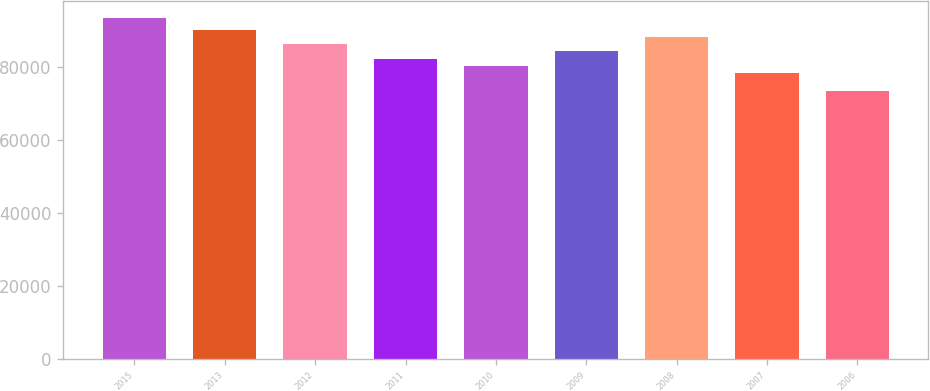Convert chart. <chart><loc_0><loc_0><loc_500><loc_500><bar_chart><fcel>2015<fcel>2013<fcel>2012<fcel>2011<fcel>2010<fcel>2009<fcel>2008<fcel>2007<fcel>2006<nl><fcel>93339<fcel>90255.6<fcel>86286.4<fcel>82317.2<fcel>80332.6<fcel>84301.8<fcel>88271<fcel>78348<fcel>73493<nl></chart> 